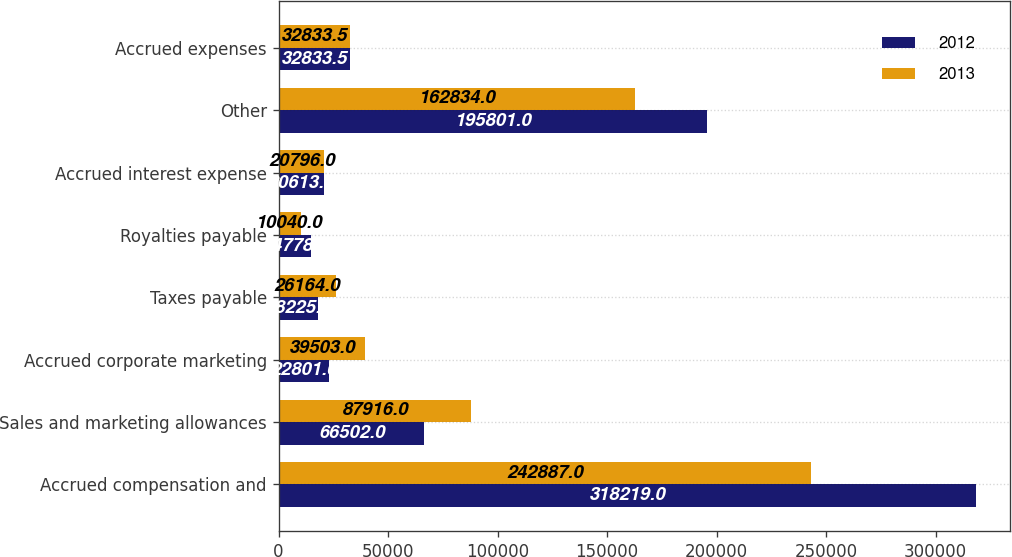<chart> <loc_0><loc_0><loc_500><loc_500><stacked_bar_chart><ecel><fcel>Accrued compensation and<fcel>Sales and marketing allowances<fcel>Accrued corporate marketing<fcel>Taxes payable<fcel>Royalties payable<fcel>Accrued interest expense<fcel>Other<fcel>Accrued expenses<nl><fcel>2012<fcel>318219<fcel>66502<fcel>22801<fcel>18225<fcel>14778<fcel>20613<fcel>195801<fcel>32833.5<nl><fcel>2013<fcel>242887<fcel>87916<fcel>39503<fcel>26164<fcel>10040<fcel>20796<fcel>162834<fcel>32833.5<nl></chart> 